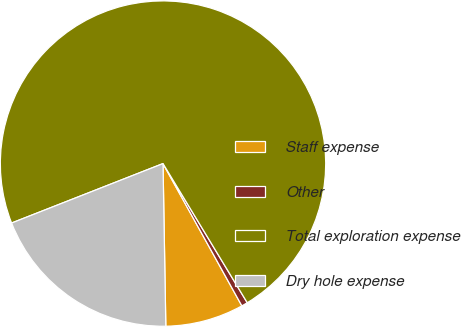<chart> <loc_0><loc_0><loc_500><loc_500><pie_chart><fcel>Staff expense<fcel>Other<fcel>Total exploration expense<fcel>Dry hole expense<nl><fcel>7.78%<fcel>0.61%<fcel>72.29%<fcel>19.32%<nl></chart> 